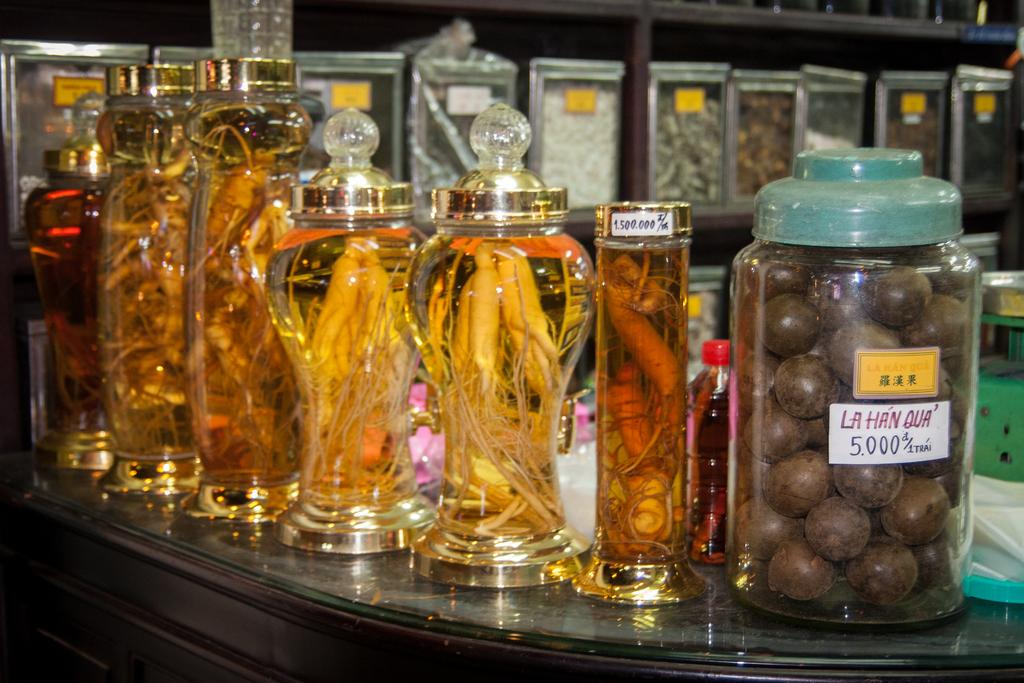<image>
Summarize the visual content of the image. Many containers with weird objects including on that says "La Han Qua". 